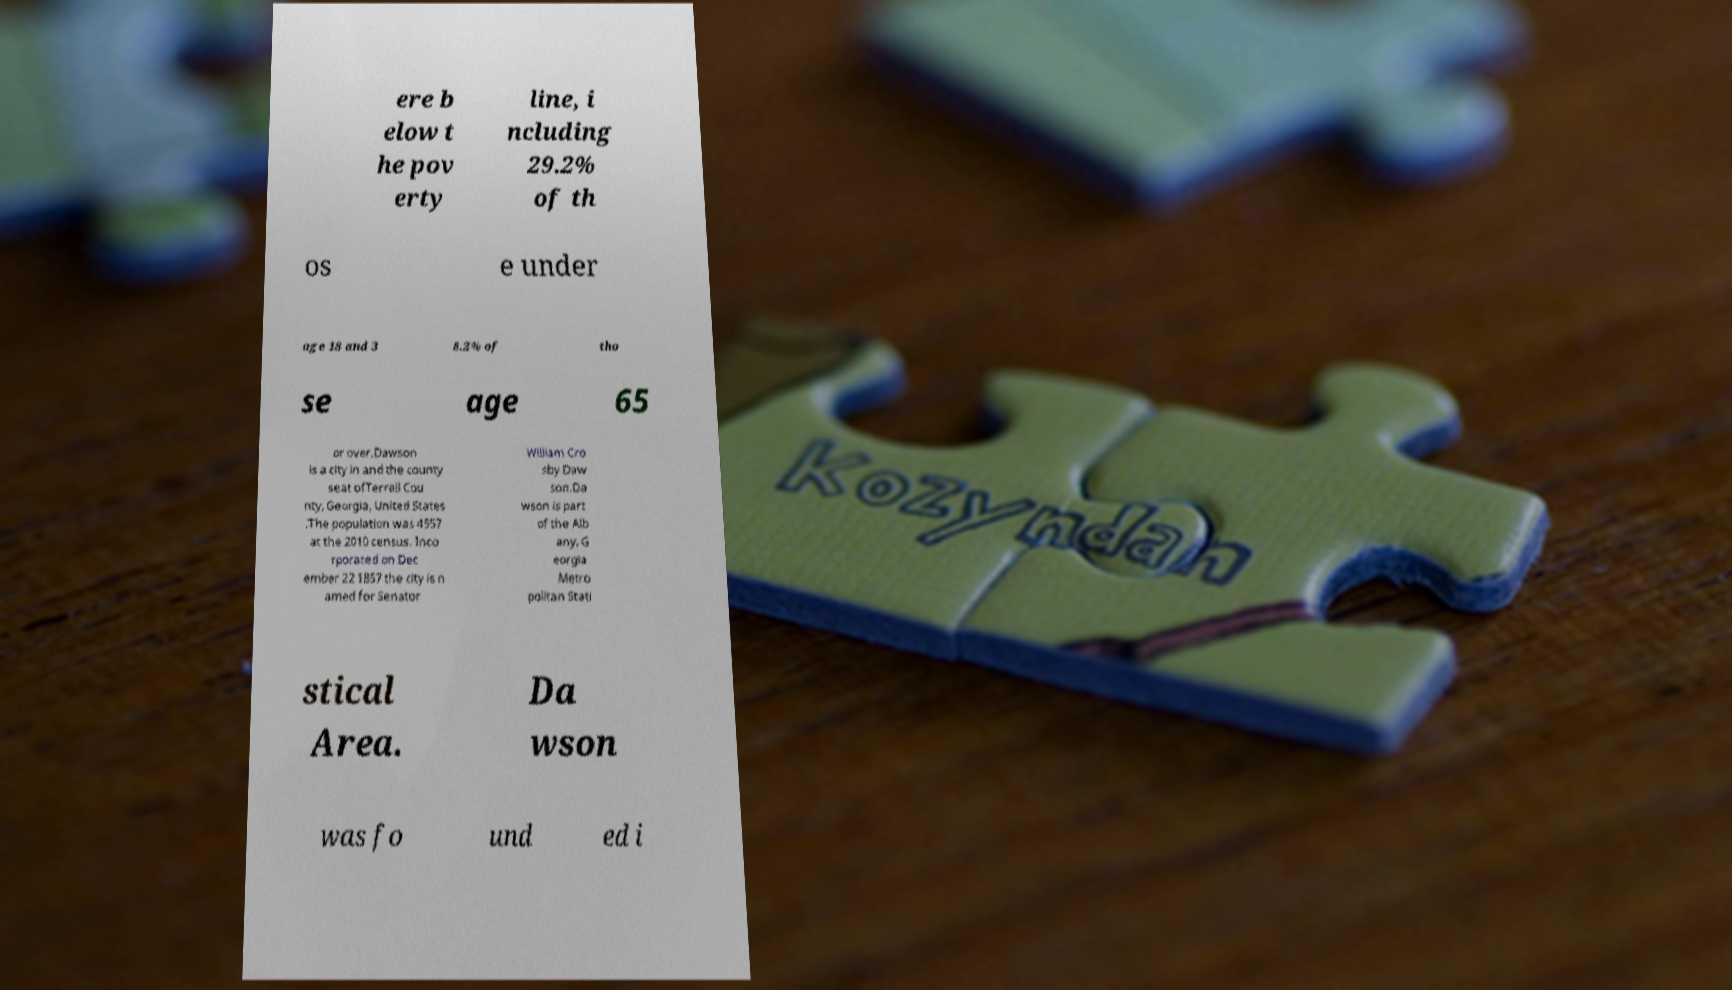For documentation purposes, I need the text within this image transcribed. Could you provide that? ere b elow t he pov erty line, i ncluding 29.2% of th os e under age 18 and 3 8.2% of tho se age 65 or over.Dawson is a city in and the county seat ofTerrell Cou nty, Georgia, United States .The population was 4557 at the 2010 census. Inco rporated on Dec ember 22 1857 the city is n amed for Senator William Cro sby Daw son.Da wson is part of the Alb any, G eorgia Metro politan Stati stical Area. Da wson was fo und ed i 